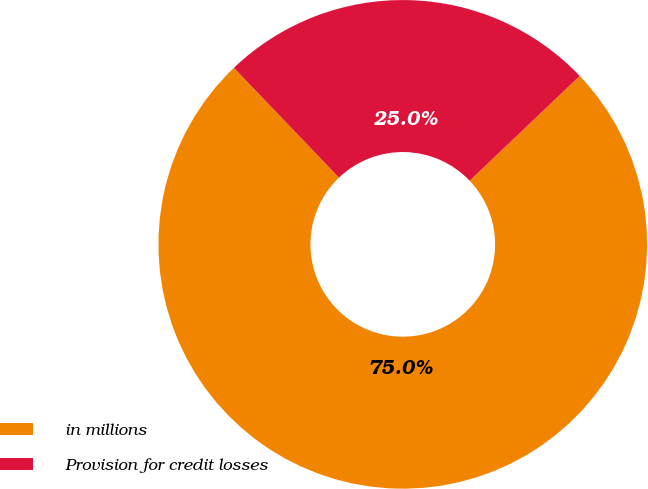Convert chart. <chart><loc_0><loc_0><loc_500><loc_500><pie_chart><fcel>in millions<fcel>Provision for credit losses<nl><fcel>74.96%<fcel>25.04%<nl></chart> 